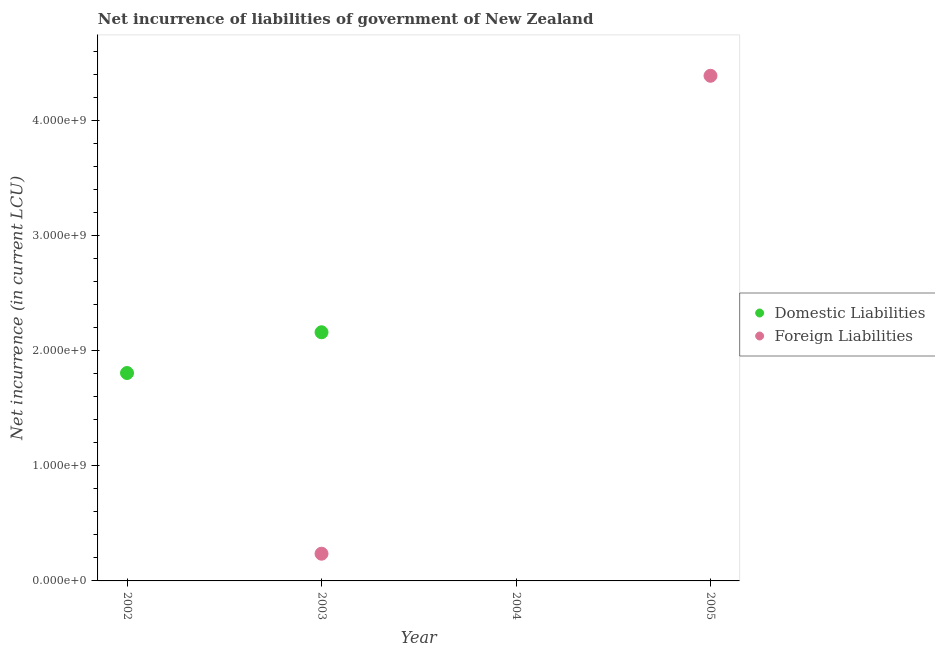How many different coloured dotlines are there?
Keep it short and to the point. 2. Is the number of dotlines equal to the number of legend labels?
Give a very brief answer. No. What is the net incurrence of foreign liabilities in 2003?
Provide a succinct answer. 2.36e+08. Across all years, what is the maximum net incurrence of domestic liabilities?
Offer a terse response. 2.16e+09. In which year was the net incurrence of foreign liabilities maximum?
Offer a very short reply. 2005. What is the total net incurrence of foreign liabilities in the graph?
Offer a very short reply. 4.62e+09. What is the difference between the net incurrence of domestic liabilities in 2002 and that in 2003?
Your answer should be compact. -3.54e+08. What is the difference between the net incurrence of foreign liabilities in 2003 and the net incurrence of domestic liabilities in 2004?
Your answer should be very brief. 2.36e+08. What is the average net incurrence of domestic liabilities per year?
Provide a short and direct response. 9.91e+08. In the year 2003, what is the difference between the net incurrence of domestic liabilities and net incurrence of foreign liabilities?
Provide a short and direct response. 1.92e+09. What is the ratio of the net incurrence of domestic liabilities in 2002 to that in 2003?
Make the answer very short. 0.84. What is the difference between the highest and the lowest net incurrence of foreign liabilities?
Provide a succinct answer. 4.39e+09. Is the sum of the net incurrence of foreign liabilities in 2003 and 2005 greater than the maximum net incurrence of domestic liabilities across all years?
Ensure brevity in your answer.  Yes. How many years are there in the graph?
Provide a succinct answer. 4. Where does the legend appear in the graph?
Your answer should be very brief. Center right. What is the title of the graph?
Offer a very short reply. Net incurrence of liabilities of government of New Zealand. What is the label or title of the Y-axis?
Give a very brief answer. Net incurrence (in current LCU). What is the Net incurrence (in current LCU) of Domestic Liabilities in 2002?
Keep it short and to the point. 1.81e+09. What is the Net incurrence (in current LCU) in Domestic Liabilities in 2003?
Your answer should be very brief. 2.16e+09. What is the Net incurrence (in current LCU) in Foreign Liabilities in 2003?
Offer a terse response. 2.36e+08. What is the Net incurrence (in current LCU) in Foreign Liabilities in 2005?
Ensure brevity in your answer.  4.39e+09. Across all years, what is the maximum Net incurrence (in current LCU) of Domestic Liabilities?
Make the answer very short. 2.16e+09. Across all years, what is the maximum Net incurrence (in current LCU) of Foreign Liabilities?
Offer a terse response. 4.39e+09. Across all years, what is the minimum Net incurrence (in current LCU) in Domestic Liabilities?
Provide a succinct answer. 0. What is the total Net incurrence (in current LCU) of Domestic Liabilities in the graph?
Provide a succinct answer. 3.96e+09. What is the total Net incurrence (in current LCU) in Foreign Liabilities in the graph?
Provide a succinct answer. 4.62e+09. What is the difference between the Net incurrence (in current LCU) of Domestic Liabilities in 2002 and that in 2003?
Ensure brevity in your answer.  -3.54e+08. What is the difference between the Net incurrence (in current LCU) in Foreign Liabilities in 2003 and that in 2005?
Offer a very short reply. -4.15e+09. What is the difference between the Net incurrence (in current LCU) of Domestic Liabilities in 2002 and the Net incurrence (in current LCU) of Foreign Liabilities in 2003?
Provide a short and direct response. 1.57e+09. What is the difference between the Net incurrence (in current LCU) in Domestic Liabilities in 2002 and the Net incurrence (in current LCU) in Foreign Liabilities in 2005?
Make the answer very short. -2.58e+09. What is the difference between the Net incurrence (in current LCU) in Domestic Liabilities in 2003 and the Net incurrence (in current LCU) in Foreign Liabilities in 2005?
Keep it short and to the point. -2.23e+09. What is the average Net incurrence (in current LCU) in Domestic Liabilities per year?
Provide a short and direct response. 9.91e+08. What is the average Net incurrence (in current LCU) of Foreign Liabilities per year?
Make the answer very short. 1.16e+09. In the year 2003, what is the difference between the Net incurrence (in current LCU) in Domestic Liabilities and Net incurrence (in current LCU) in Foreign Liabilities?
Offer a very short reply. 1.92e+09. What is the ratio of the Net incurrence (in current LCU) of Domestic Liabilities in 2002 to that in 2003?
Your answer should be compact. 0.84. What is the ratio of the Net incurrence (in current LCU) of Foreign Liabilities in 2003 to that in 2005?
Your answer should be very brief. 0.05. What is the difference between the highest and the lowest Net incurrence (in current LCU) in Domestic Liabilities?
Make the answer very short. 2.16e+09. What is the difference between the highest and the lowest Net incurrence (in current LCU) of Foreign Liabilities?
Your response must be concise. 4.39e+09. 